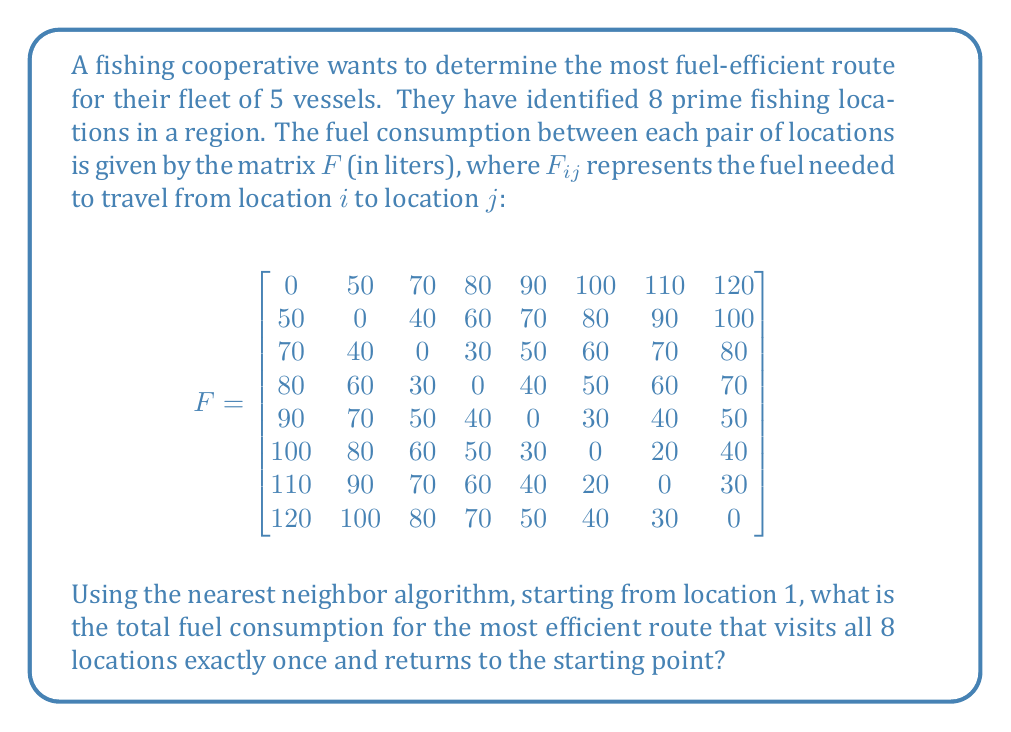What is the answer to this math problem? To solve this problem, we'll use the nearest neighbor algorithm, which is a simple heuristic for solving the Traveling Salesman Problem. Here's how we'll proceed:

1. Start at location 1.
2. Find the nearest unvisited location (the one with the lowest fuel consumption).
3. Move to that location and mark it as visited.
4. Repeat steps 2 and 3 until all locations have been visited.
5. Return to the starting location.

Let's go through this step-by-step:

1. Start at location 1.
   Visited: [1]

2. From location 1, the nearest location is 2 (50 liters).
   Fuel used: 50 liters
   Visited: [1, 2]

3. From location 2, the nearest unvisited location is 3 (40 liters).
   Fuel used: 50 + 40 = 90 liters
   Visited: [1, 2, 3]

4. From location 3, the nearest unvisited location is 4 (30 liters).
   Fuel used: 90 + 30 = 120 liters
   Visited: [1, 2, 3, 4]

5. From location 4, the nearest unvisited location is 5 (40 liters).
   Fuel used: 120 + 40 = 160 liters
   Visited: [1, 2, 3, 4, 5]

6. From location 5, the nearest unvisited location is 6 (30 liters).
   Fuel used: 160 + 30 = 190 liters
   Visited: [1, 2, 3, 4, 5, 6]

7. From location 6, the nearest unvisited location is 7 (20 liters).
   Fuel used: 190 + 20 = 210 liters
   Visited: [1, 2, 3, 4, 5, 6, 7]

8. The only unvisited location is 8, so we go there (30 liters).
   Fuel used: 210 + 30 = 240 liters
   Visited: [1, 2, 3, 4, 5, 6, 7, 8]

9. Finally, return to the starting point, location 1 (120 liters).
   Total fuel used: 240 + 120 = 360 liters

The route found is: 1 → 2 → 3 → 4 → 5 → 6 → 7 → 8 → 1

Therefore, the total fuel consumption for the most efficient route using the nearest neighbor algorithm is 360 liters.
Answer: 360 liters 